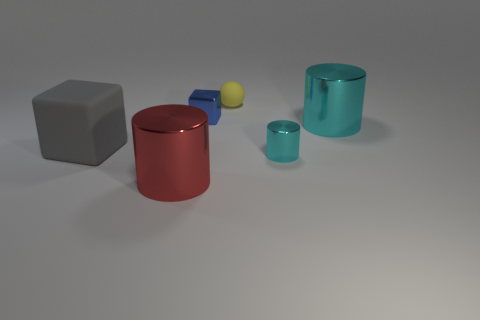Add 3 big metal cylinders. How many objects exist? 9 Subtract all cubes. How many objects are left? 4 Add 6 large red things. How many large red things are left? 7 Add 1 red metallic objects. How many red metallic objects exist? 2 Subtract 0 brown cylinders. How many objects are left? 6 Subtract all cylinders. Subtract all big brown balls. How many objects are left? 3 